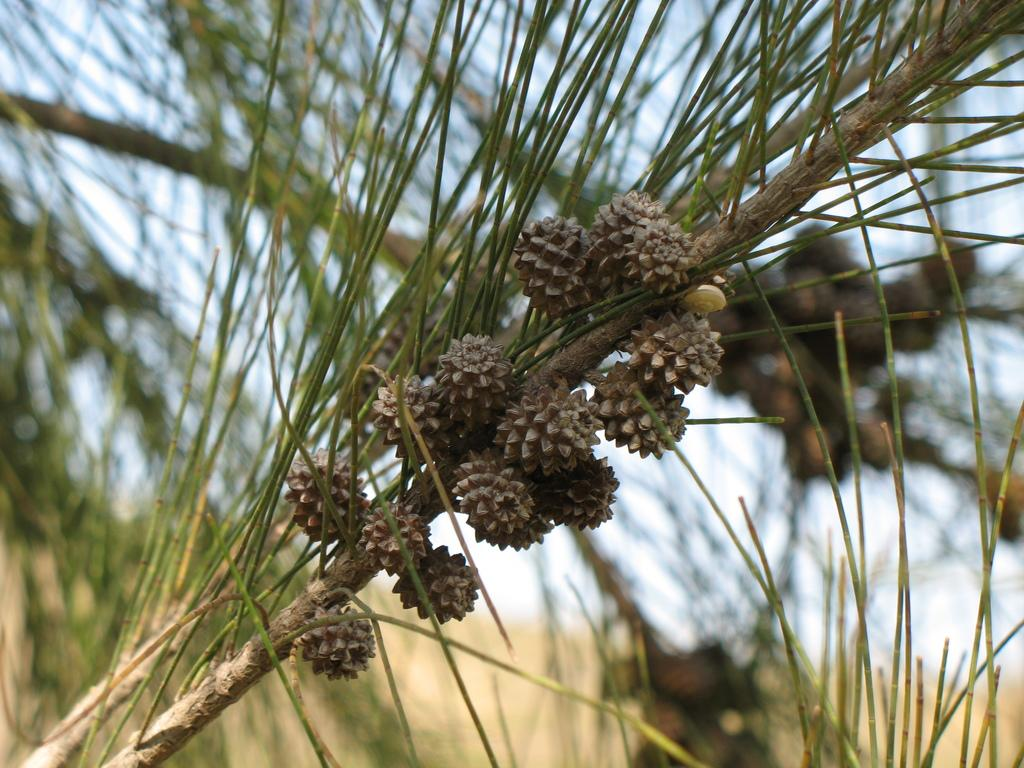What type of vegetation is present in the image? There are trees with fruits in the image. What is the condition of the sky in the image? The sky is cloudy in the image. What type of stew is being served at the protest in the cemetery in the image? There is no protest, cemetery, or stew present in the image. The image only features trees with fruits and a cloudy sky. 